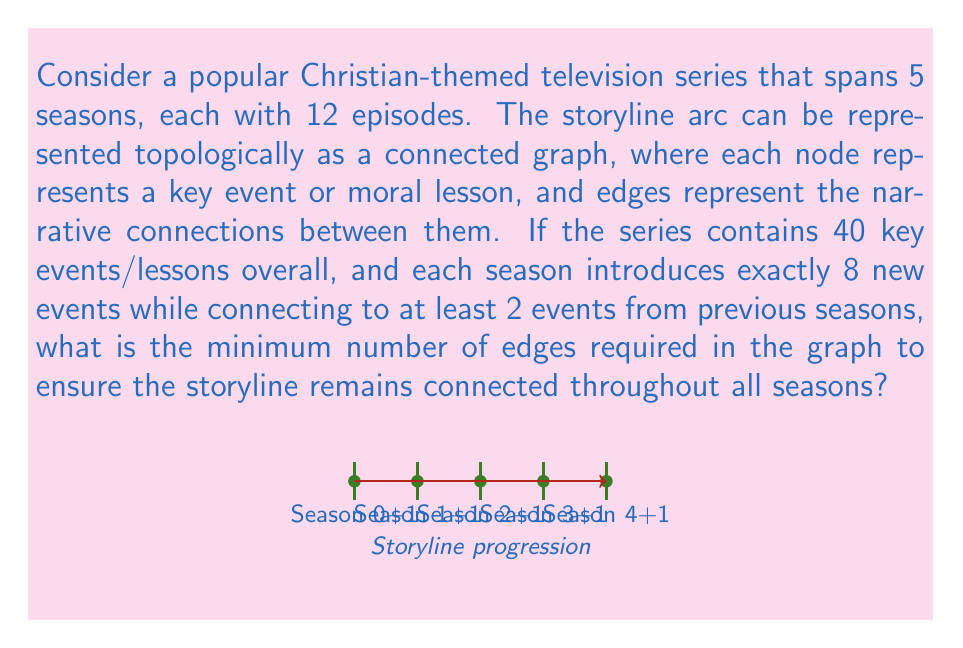Help me with this question. Let's approach this step-by-step:

1) First, let's consider the number of nodes (events/lessons) per season:
   Season 1: 8 new events
   Season 2-5: 8 new events each, plus at least 2 connections to previous events
   Total: $8 + 4 \times 8 = 40$ events (as given)

2) To ensure the graph is connected, we need at least $n-1$ edges, where $n$ is the number of nodes. So the minimum number of edges is 39.

3) However, we need to account for the additional connections between seasons:
   - Season 2 needs at least 2 connections to Season 1
   - Season 3 needs at least 2 connections to Seasons 1-2
   - Season 4 needs at least 2 connections to Seasons 1-3
   - Season 5 needs at least 2 connections to Seasons 1-4

4) Let's count these additional edges:
   $2 + 2 + 2 + 2 = 8$ additional edges

5) Therefore, the minimum number of edges required is:
   $39 + 8 = 47$

This ensures that the storyline remains connected throughout all seasons while satisfying the given conditions.
Answer: 47 edges 